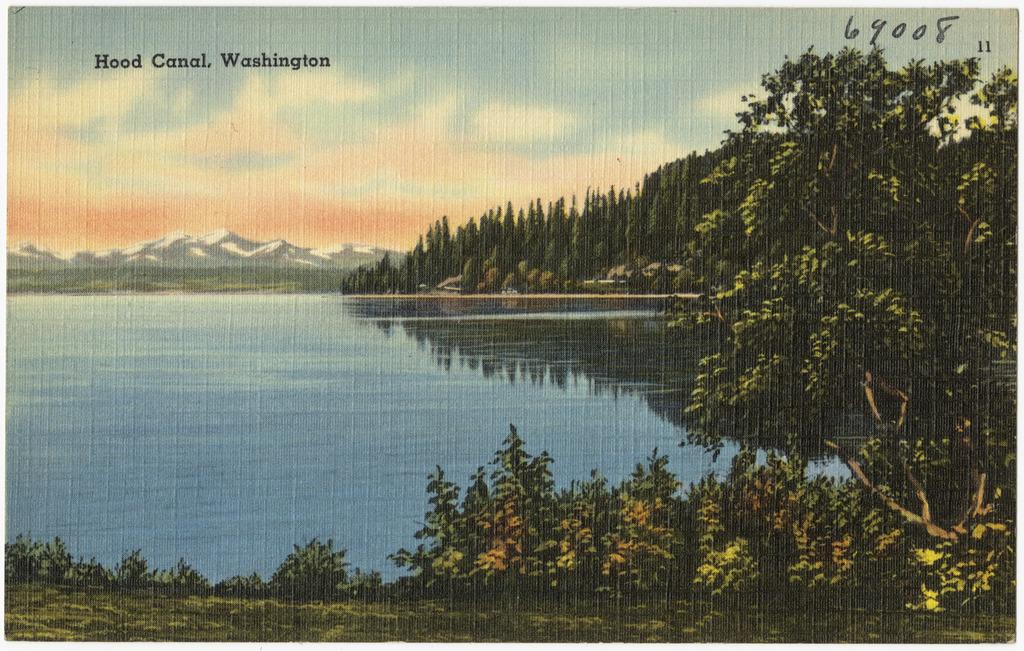What type of natural landforms can be seen in the image? There are mountains in the image. What type of vegetation is present in the image? There are trees, plants, and grass in the image. What body of water is visible in the image? There is a river in the image. What part of the natural environment is visible in the image? The sky is visible in the image. Is there any text present in the image? Yes, there is text on the image. Can you tell me how many slices of bread are floating in the river in the image? There is no bread present in the image, and therefore no such activity can be observed. 